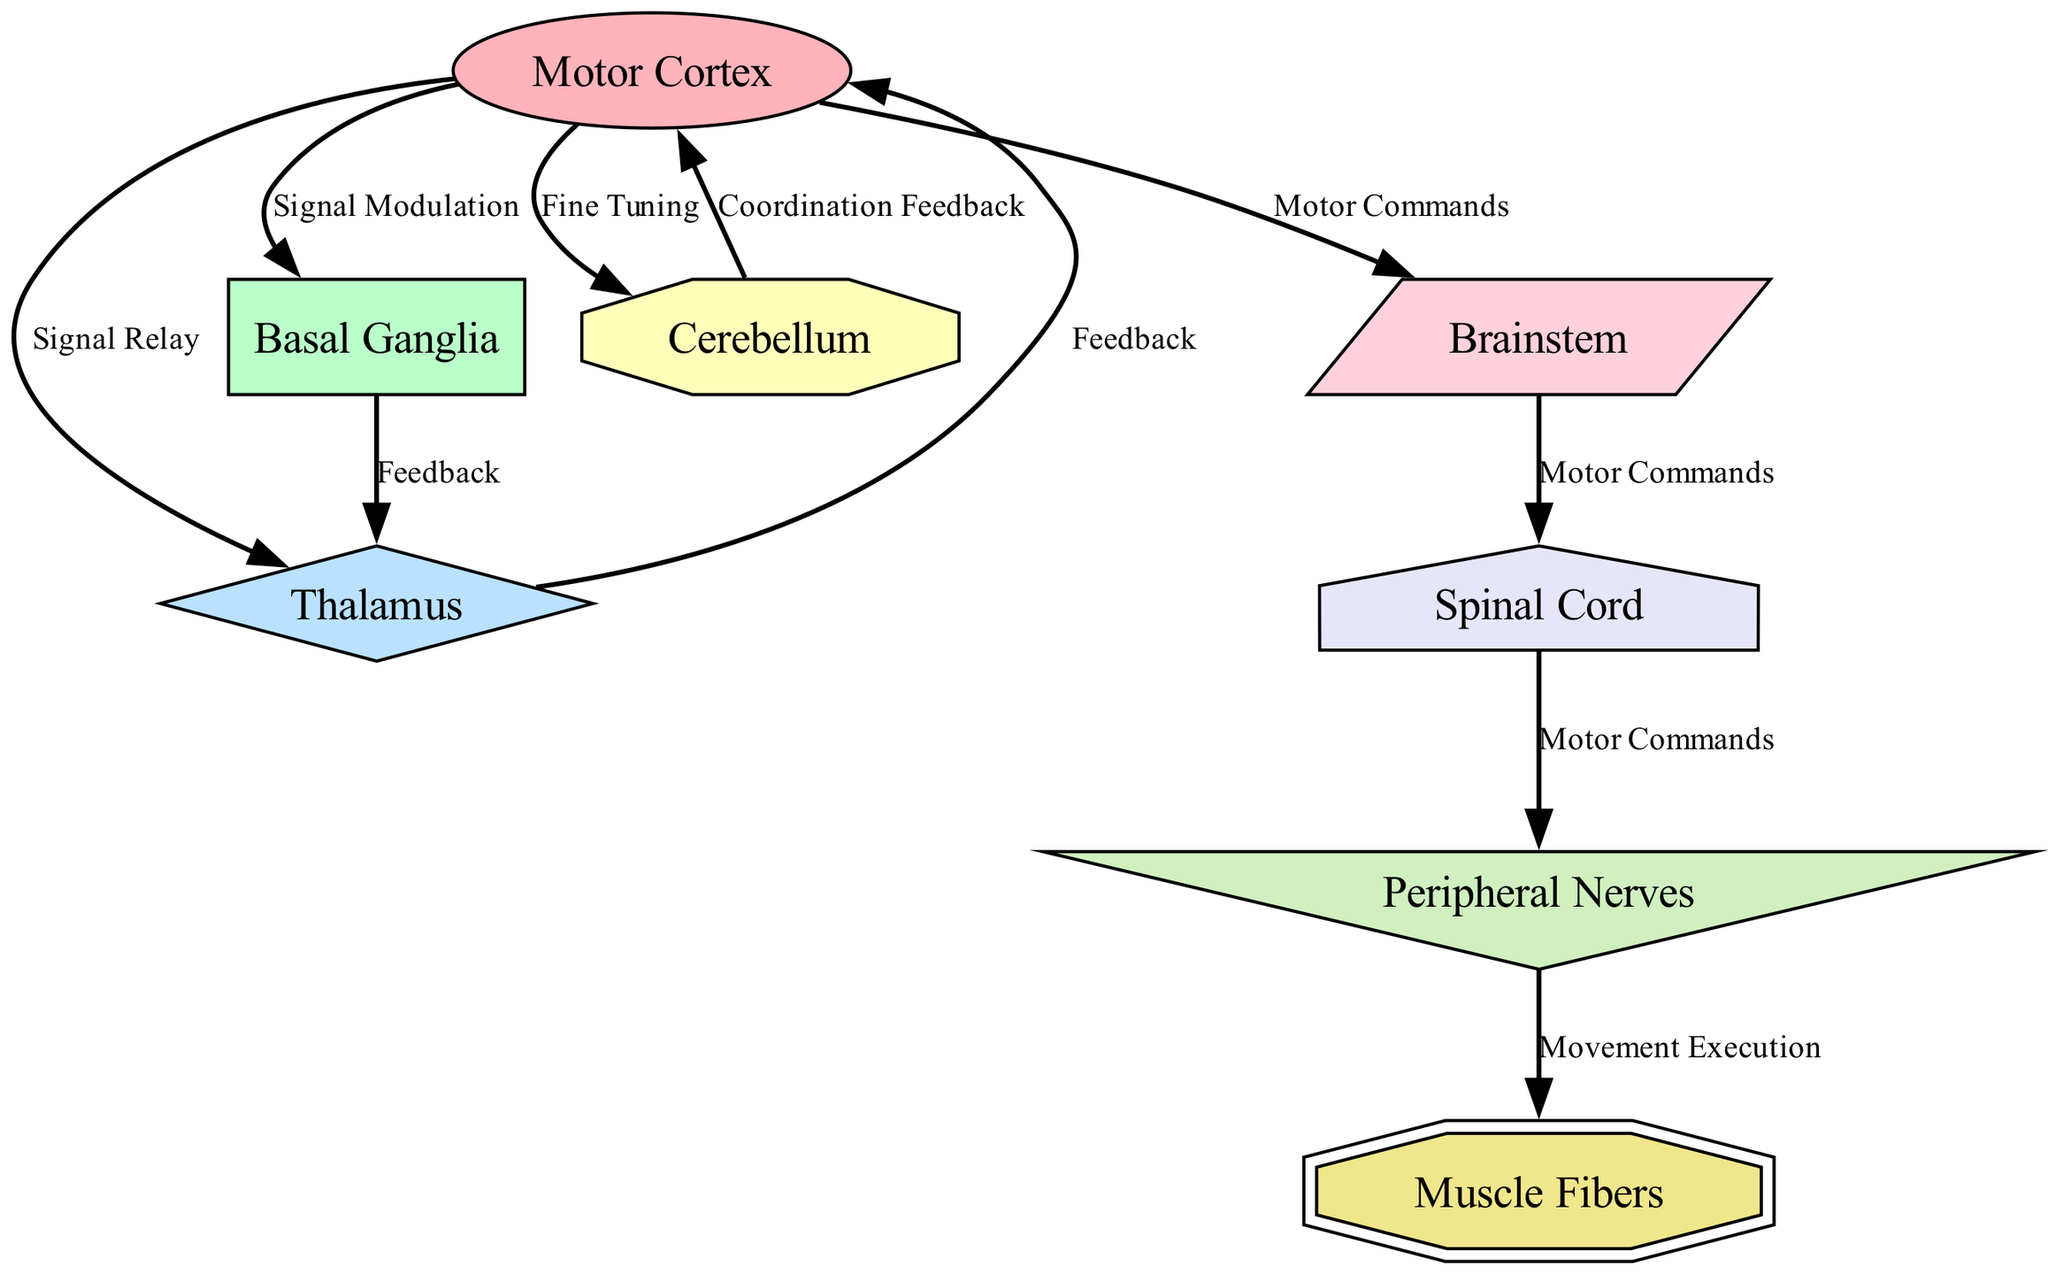What is the first node in the pathway? The first node in the pathway from the Motor Cortex is the Basal Ganglia, which is connected via "Signal Modulation".
Answer: Basal Ganglia How many nodes are depicted in this diagram? There are a total of eight nodes represented in the diagram: Motor Cortex, Basal Ganglia, Thalamus, Cerebellum, Brainstem, Spinal Cord, Peripheral Nerves, and Muscle Fibers.
Answer: Eight What type of edge connects the Motor Cortex to the Thalamus? The edge connecting the Motor Cortex to the Thalamus is labeled as "Signal Relay". This indicates that the Motor Cortex sends signals to the Thalamus for further processing.
Answer: Signal Relay Which node receives feedback from the Basal Ganglia? The Thalamus receives feedback from the Basal Ganglia, as indicated by the labeled edge "Feedback" connecting the two nodes.
Answer: Thalamus How do signals travel from the Brainstem to the Muscle Fibers? Signals journey from the Brainstem to the Muscle Fibers through a series of connections: the Brainstem sends motor commands to the Spinal Cord, which then passes them to the Peripheral Nerves, finally reaching the Muscle Fibers for movement execution.
Answer: Motor Commands What role does the Cerebellum play in the motor control pathway? The Cerebellum's role is to provide "Coordination Feedback" to the Motor Cortex, helping to refine and adjust movements based on sensory input from previous actions.
Answer: Coordination Feedback How many edges are present in the diagram? There are ten edges depicted in the diagram, representing the connections and interactions between the various nodes in the motor control pathway.
Answer: Ten What is the last step in executing movement as shown in the diagram? The final step in executing movement is when the Peripheral Nerves send signals to the Muscle Fibers, which is illustrated in the edge labeled "Movement Execution".
Answer: Movement Execution What connects the Spinal Cord and the Peripheral Nerves? The Spinal Cord is connected to the Peripheral Nerves by an edge labeled "Motor Commands", indicating the transmission of motor signals along this pathway.
Answer: Motor Commands 